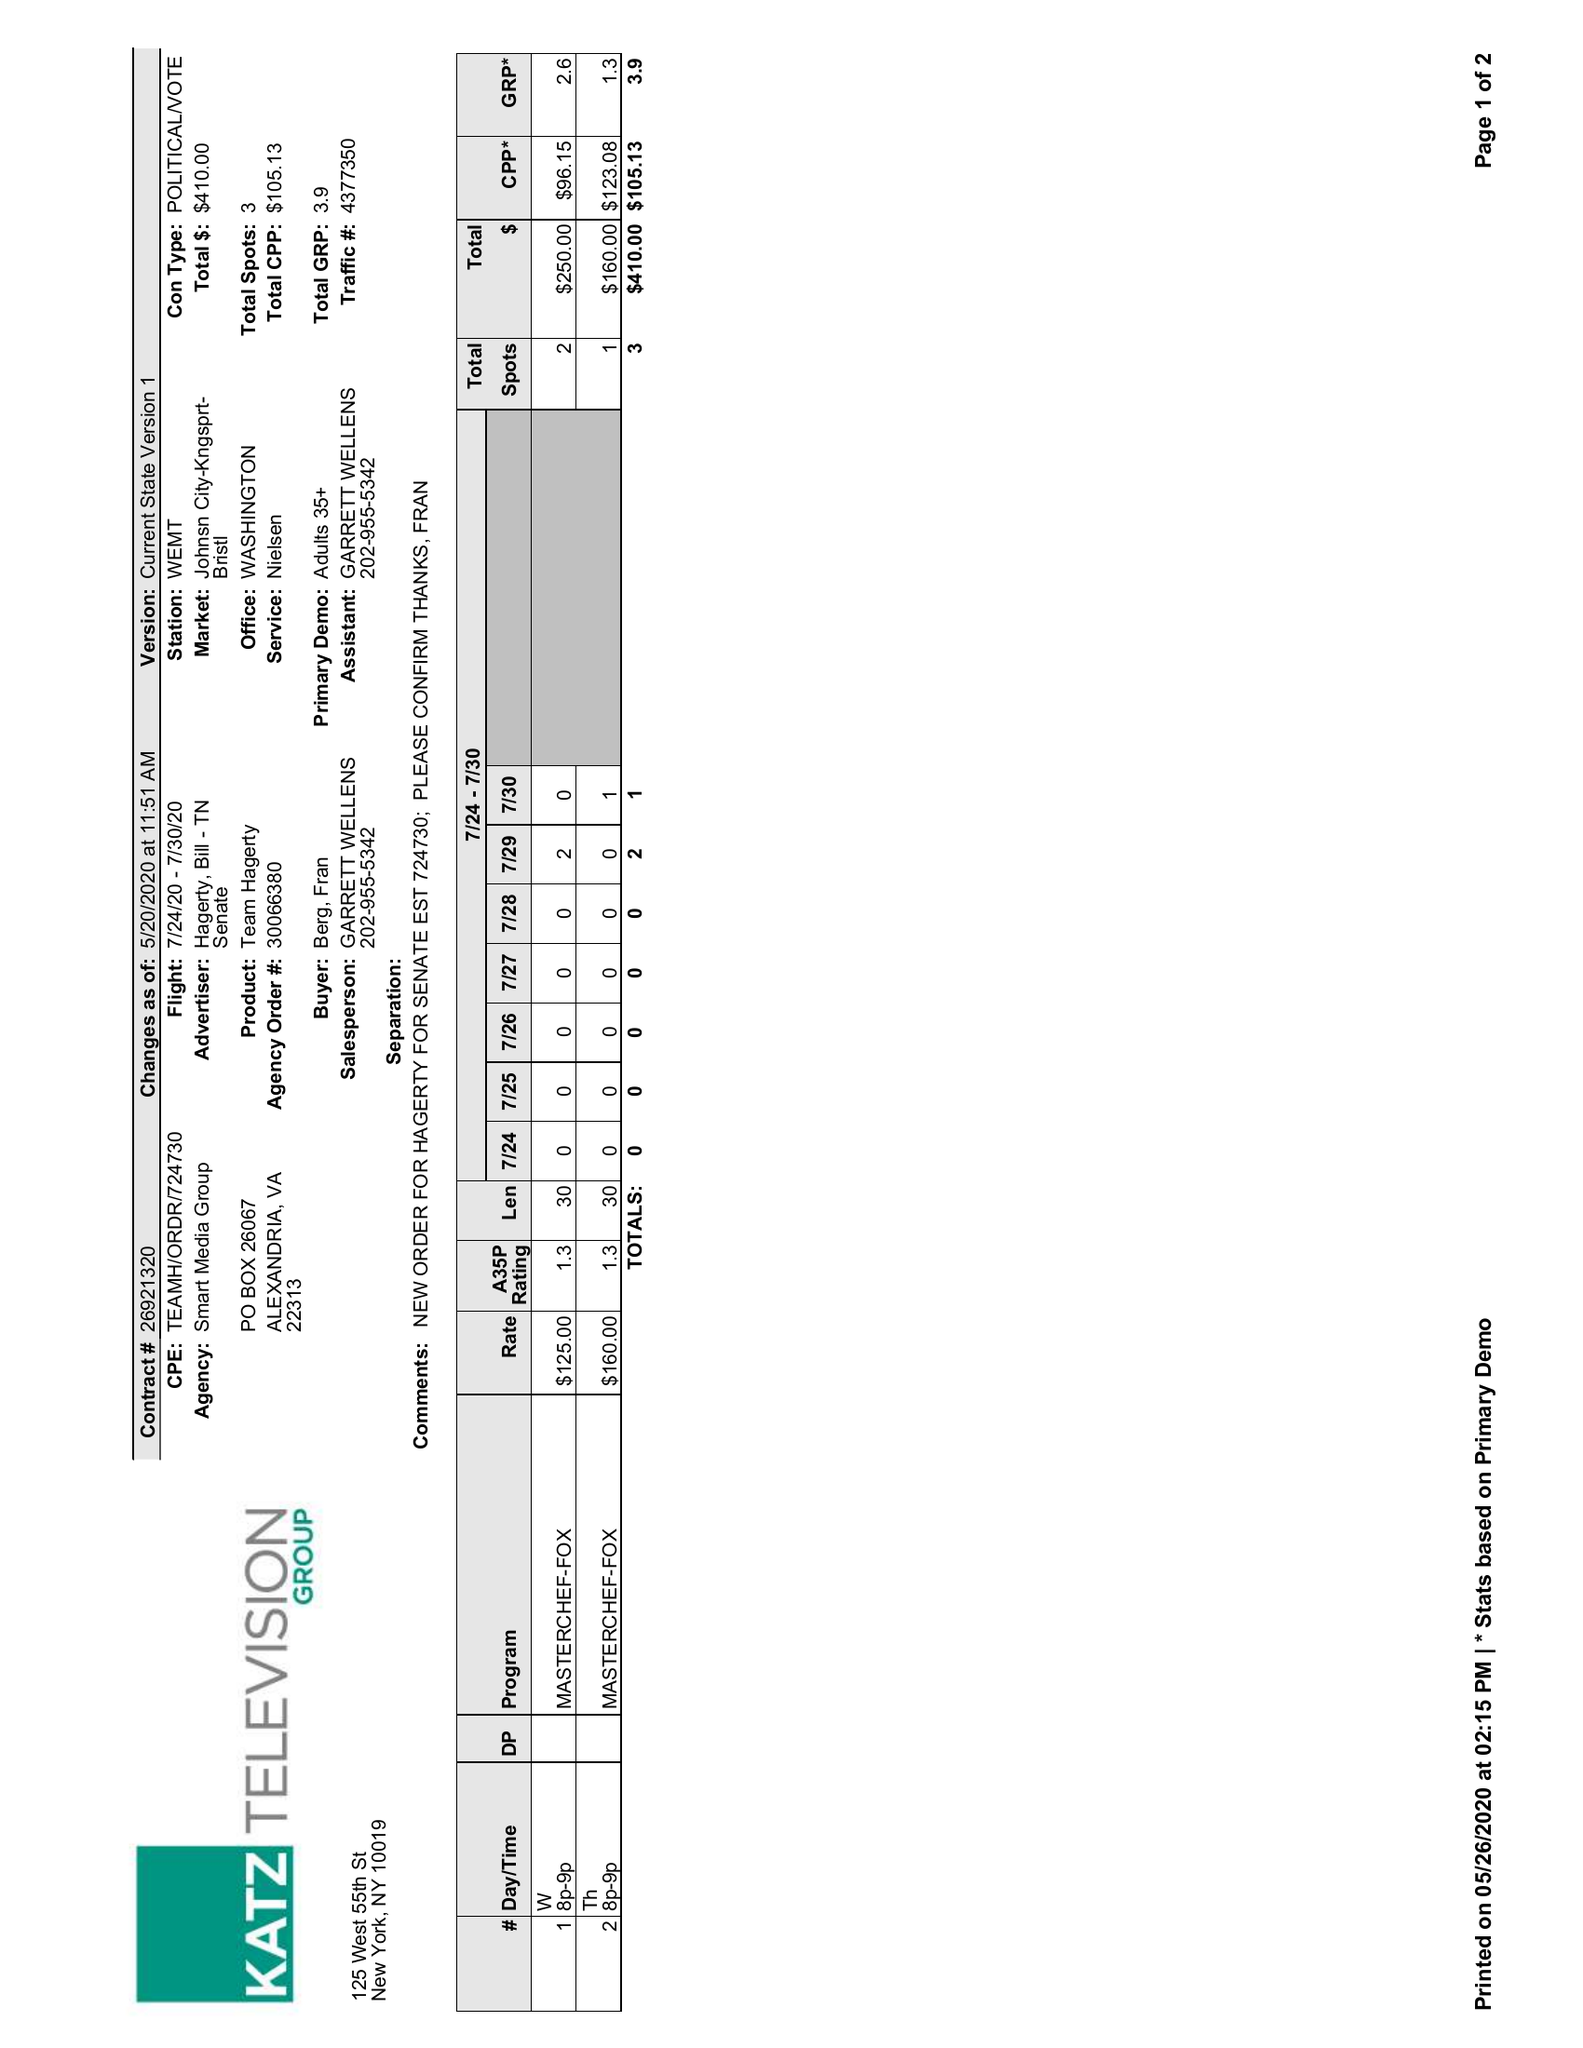What is the value for the gross_amount?
Answer the question using a single word or phrase. 410.00 